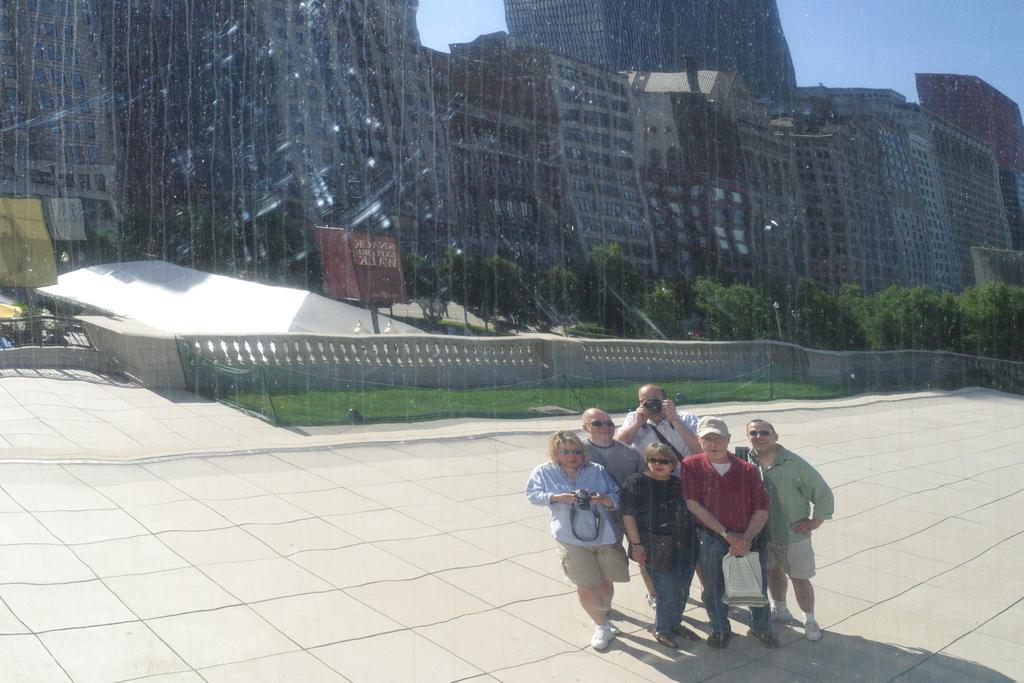Could you give a brief overview of what you see in this image? In this image, we can see people on the road and are holding some objects and some are wearing glasses. In the background, there are buildings and we can see boards, trees and there is a fence. At the top, there is sky. 